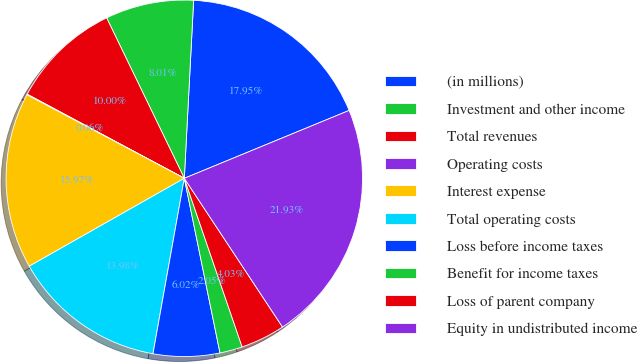Convert chart. <chart><loc_0><loc_0><loc_500><loc_500><pie_chart><fcel>(in millions)<fcel>Investment and other income<fcel>Total revenues<fcel>Operating costs<fcel>Interest expense<fcel>Total operating costs<fcel>Loss before income taxes<fcel>Benefit for income taxes<fcel>Loss of parent company<fcel>Equity in undistributed income<nl><fcel>17.95%<fcel>8.01%<fcel>10.0%<fcel>0.06%<fcel>15.97%<fcel>13.98%<fcel>6.02%<fcel>2.05%<fcel>4.03%<fcel>21.93%<nl></chart> 